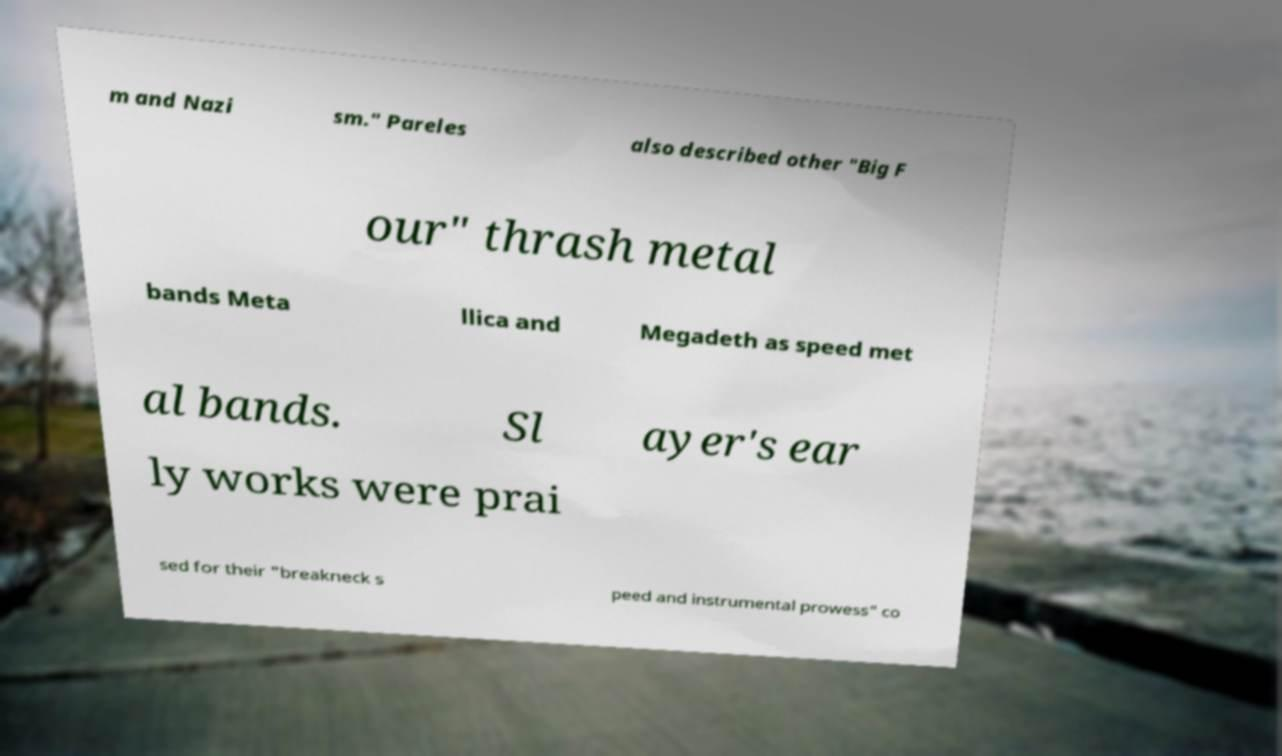Please read and relay the text visible in this image. What does it say? m and Nazi sm." Pareles also described other "Big F our" thrash metal bands Meta llica and Megadeth as speed met al bands. Sl ayer's ear ly works were prai sed for their "breakneck s peed and instrumental prowess" co 